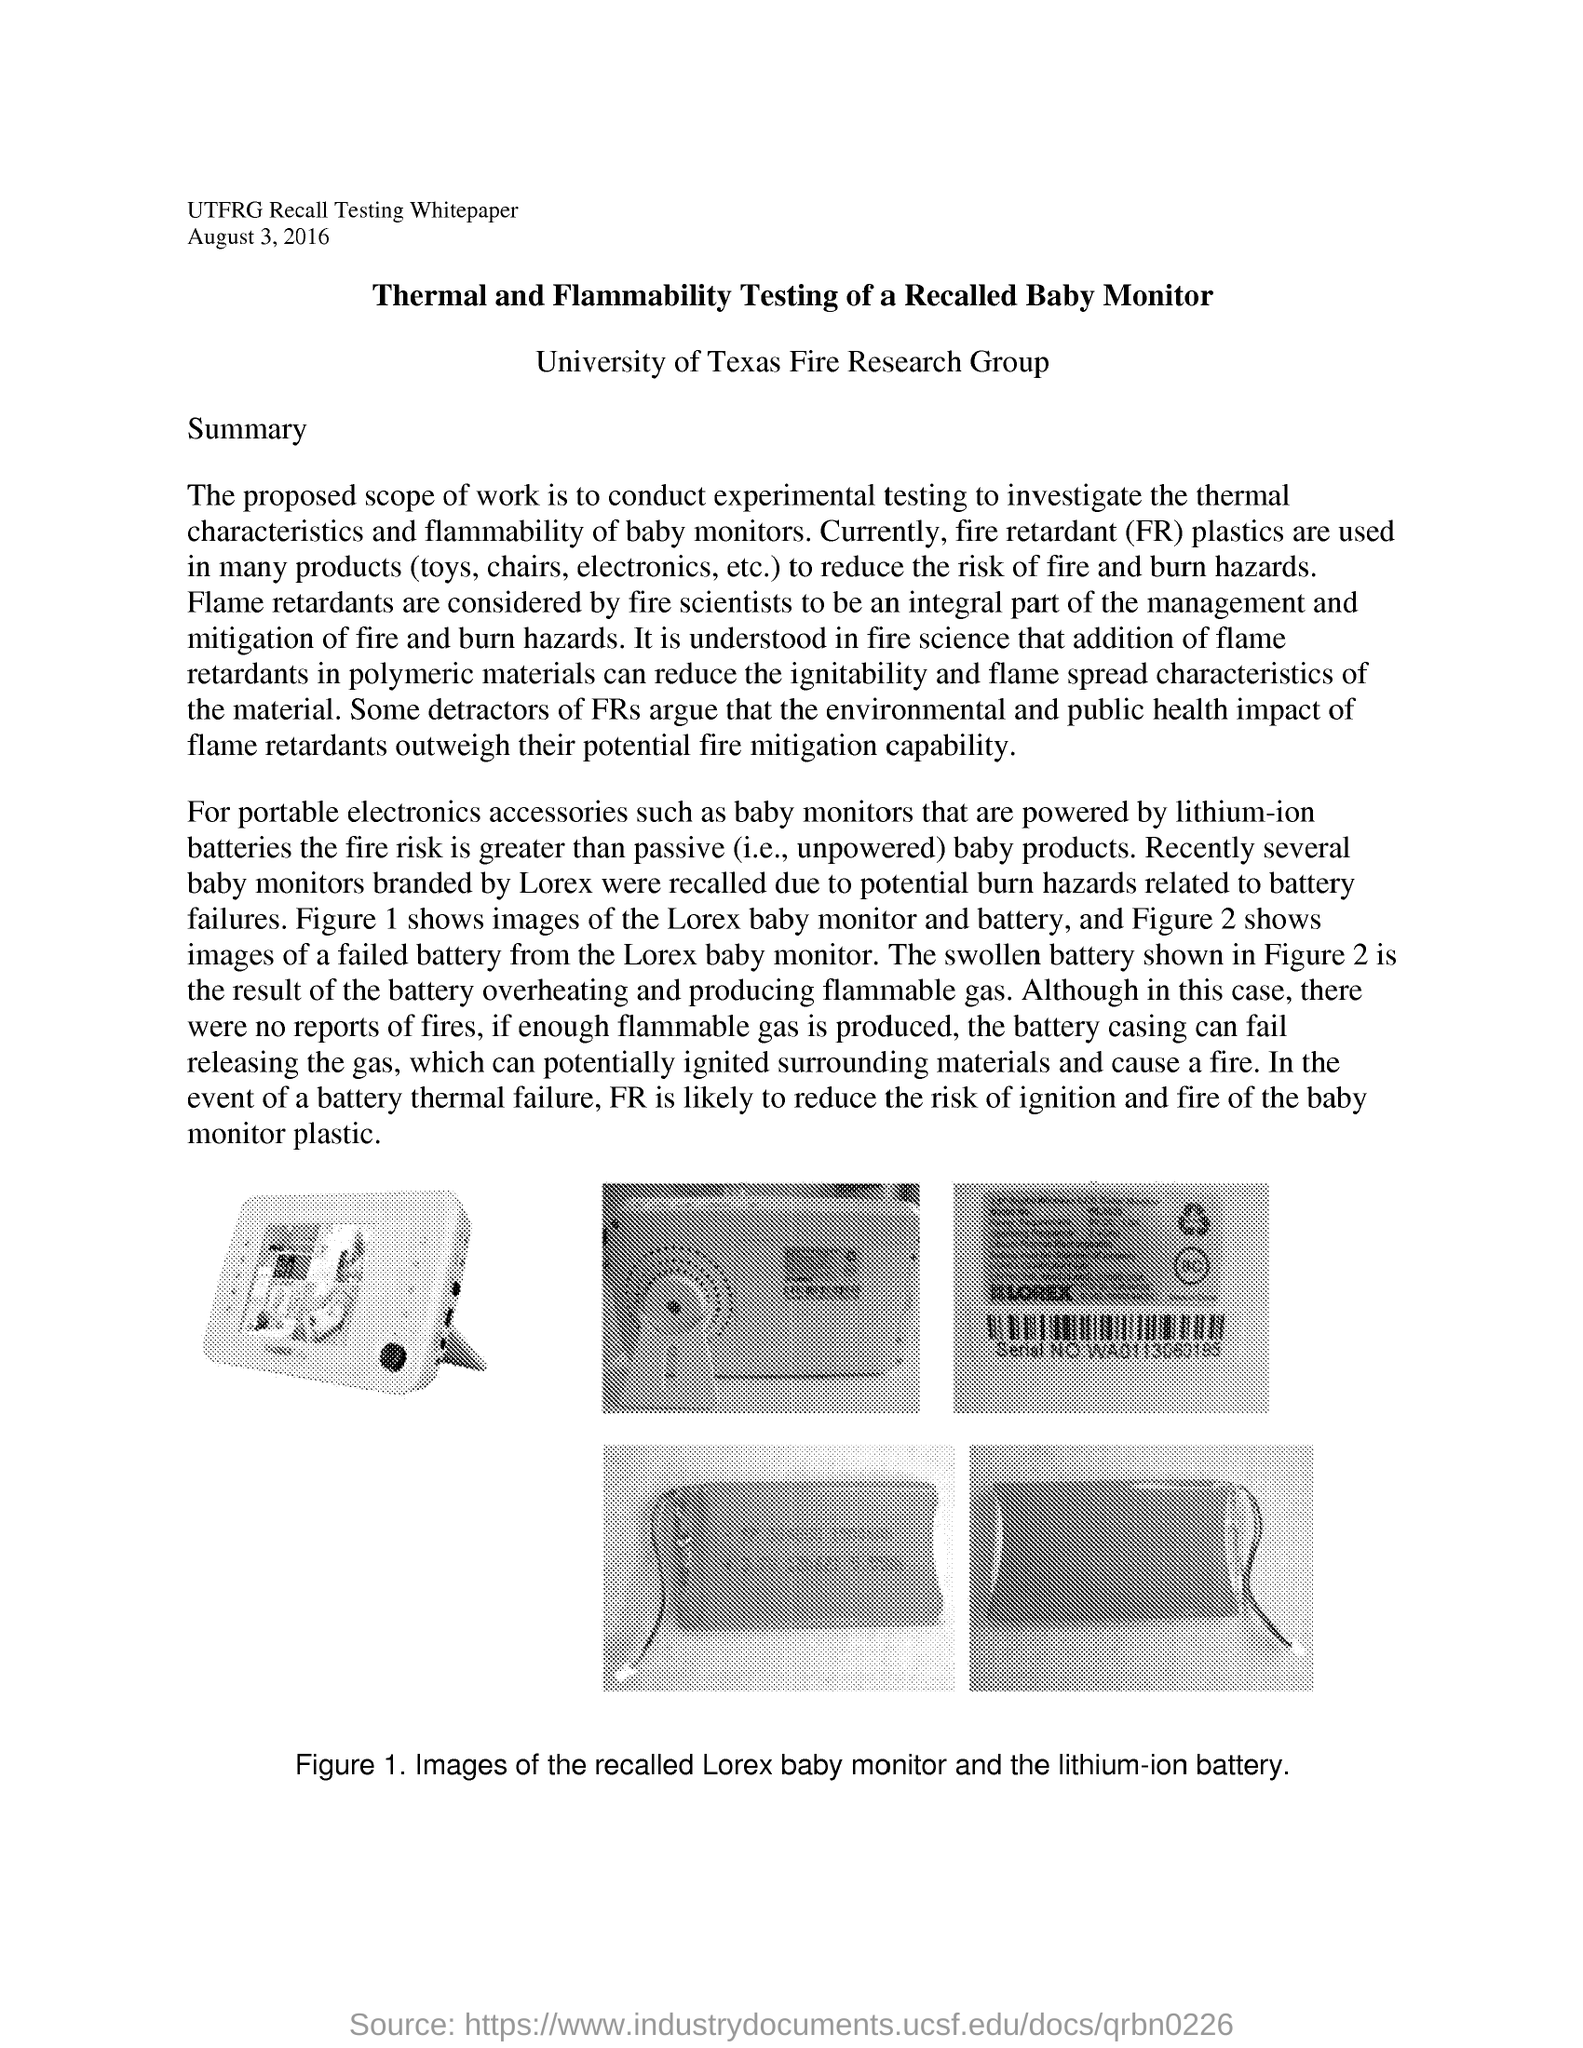What does FR stand for?
Provide a succinct answer. Fire retardant. What is the use of fire retardant plastics?
Keep it short and to the point. Fire Retardant (FR) plastics are used in many products(toys, chairs, electronics, etc.) to reduce the risk of fire and burn hazards. What happens if enough flammable gas is produced ?
Provide a succinct answer. The battery casing can fail releasing the gas, which can potentially ignited surrounding materials and cause a fire. 